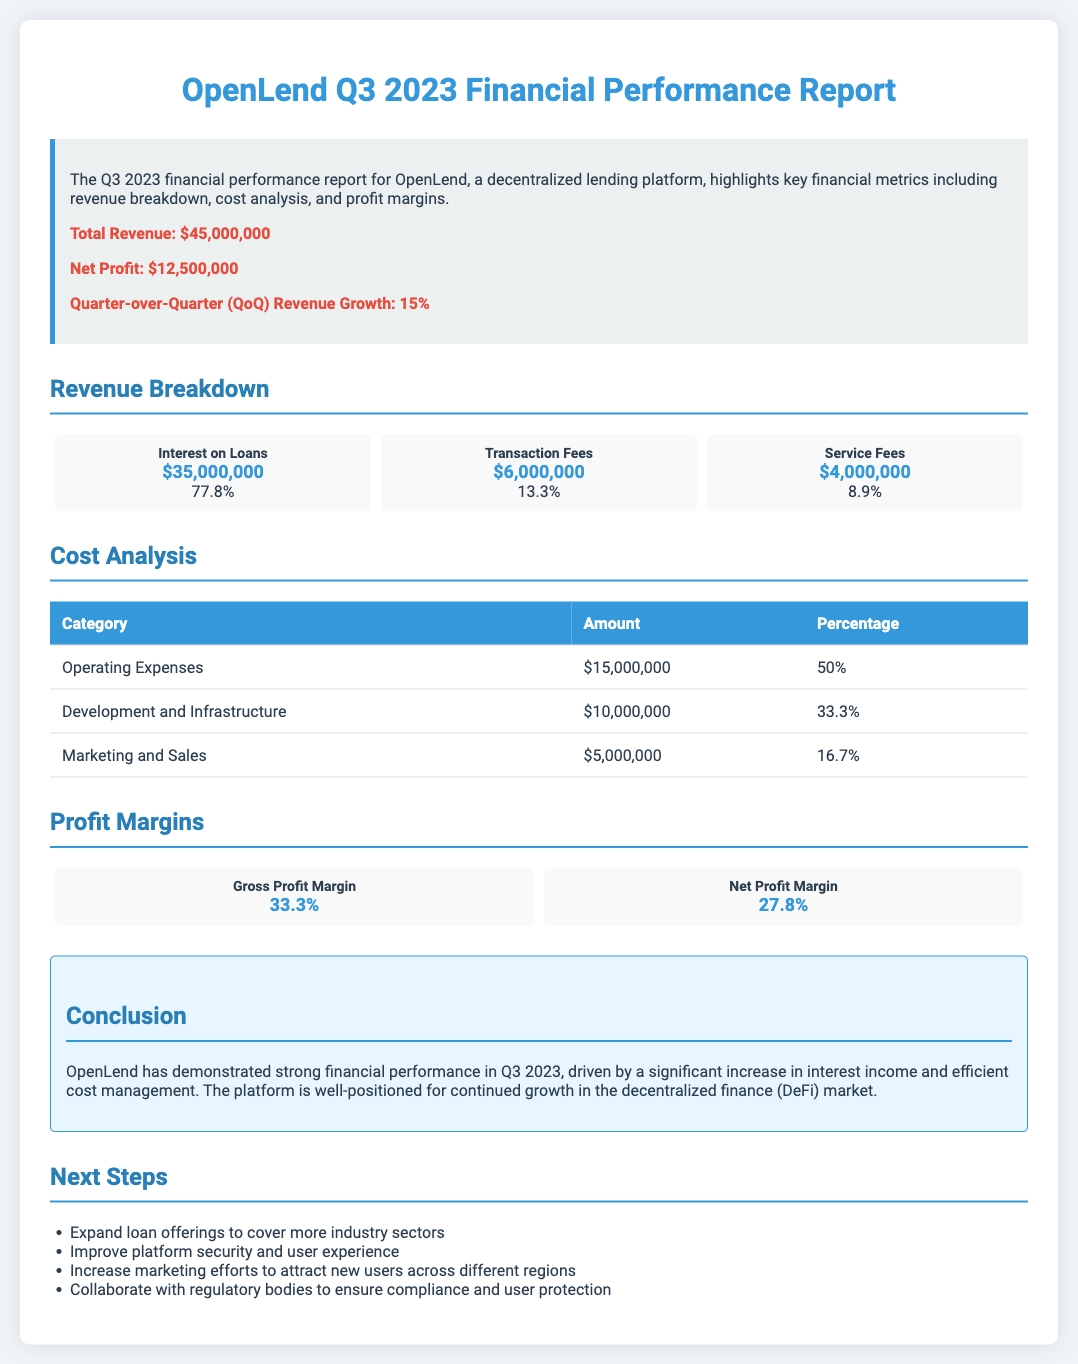What is the total revenue? The total revenue is highlighted in the summary section of the report as $45,000,000.
Answer: $45,000,000 What is the net profit for Q3 2023? The net profit is specified in the summary section of the report as $12,500,000.
Answer: $12,500,000 What percentage of total revenue comes from interest on loans? The document states that interest on loans contributes 77.8% of the total revenue.
Answer: 77.8% What are the operating expenses for Q3 2023? Operating expenses are listed in the cost analysis table, amounting to $15,000,000.
Answer: $15,000,000 What is the gross profit margin for OpenLend? The gross profit margin is presented in the profit margins section as 33.3%.
Answer: 33.3% What is the quarter-over-quarter revenue growth percentage? The quarter-over-quarter revenue growth highlighted in the summary is 15%.
Answer: 15% How much did OpenLend spend on marketing and sales? The cost analysis table specifies that marketing and sales expenditures were $5,000,000.
Answer: $5,000,000 What is the total amount collected from transaction fees? The revenue breakdown shows that transaction fees generated $6,000,000.
Answer: $6,000,000 What action is recommended to attract new users? The next steps section suggests increasing marketing efforts to attract new users.
Answer: Increase marketing efforts 